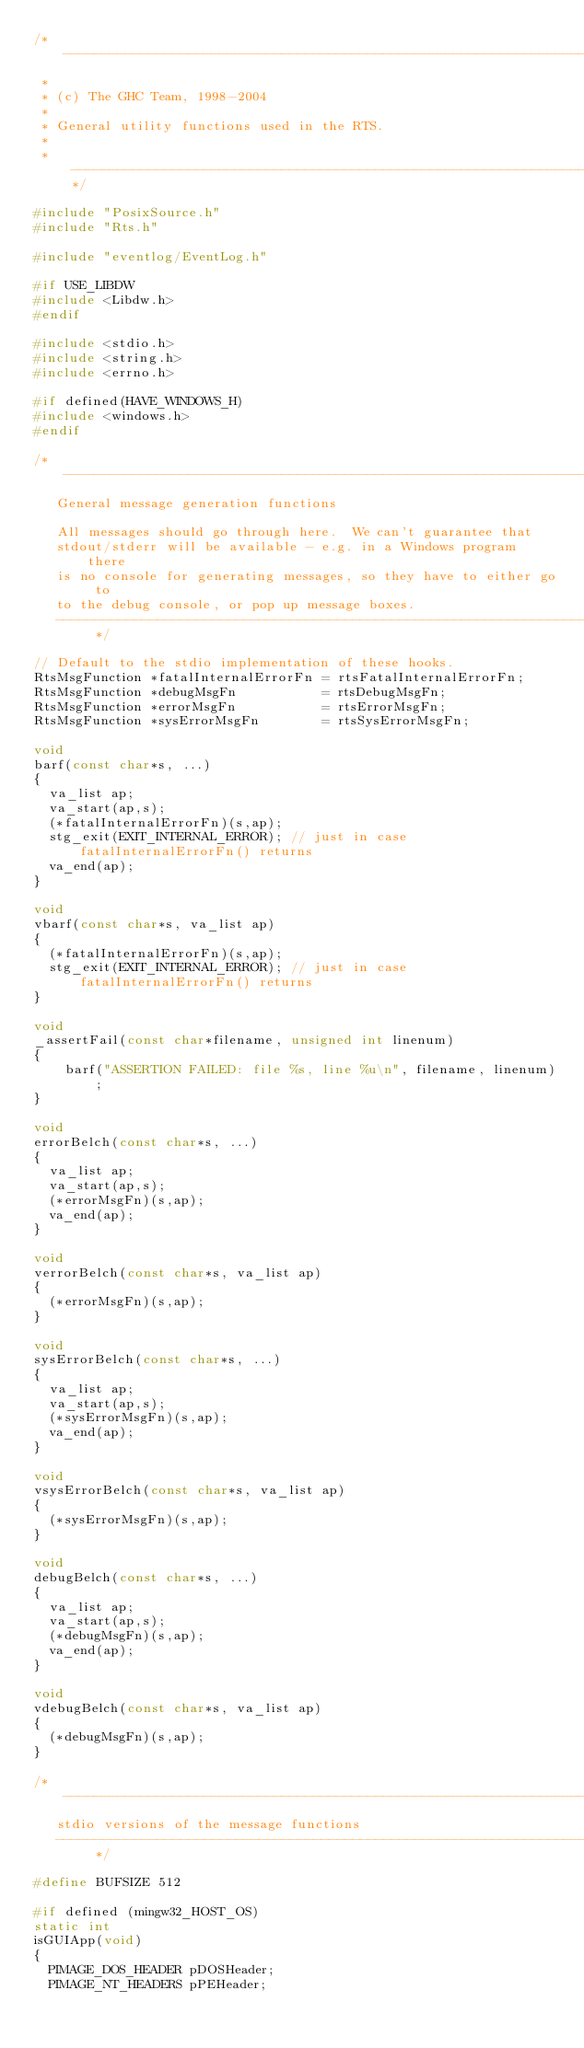<code> <loc_0><loc_0><loc_500><loc_500><_C_>/* -----------------------------------------------------------------------------
 *
 * (c) The GHC Team, 1998-2004
 *
 * General utility functions used in the RTS.
 *
 * ---------------------------------------------------------------------------*/

#include "PosixSource.h"
#include "Rts.h"

#include "eventlog/EventLog.h"

#if USE_LIBDW
#include <Libdw.h>
#endif

#include <stdio.h>
#include <string.h>
#include <errno.h>

#if defined(HAVE_WINDOWS_H)
#include <windows.h>
#endif

/* -----------------------------------------------------------------------------
   General message generation functions

   All messages should go through here.  We can't guarantee that
   stdout/stderr will be available - e.g. in a Windows program there
   is no console for generating messages, so they have to either go to
   to the debug console, or pop up message boxes.
   -------------------------------------------------------------------------- */

// Default to the stdio implementation of these hooks.
RtsMsgFunction *fatalInternalErrorFn = rtsFatalInternalErrorFn;
RtsMsgFunction *debugMsgFn           = rtsDebugMsgFn;
RtsMsgFunction *errorMsgFn           = rtsErrorMsgFn;
RtsMsgFunction *sysErrorMsgFn        = rtsSysErrorMsgFn;

void
barf(const char*s, ...)
{
  va_list ap;
  va_start(ap,s);
  (*fatalInternalErrorFn)(s,ap);
  stg_exit(EXIT_INTERNAL_ERROR); // just in case fatalInternalErrorFn() returns
  va_end(ap);
}

void
vbarf(const char*s, va_list ap)
{
  (*fatalInternalErrorFn)(s,ap);
  stg_exit(EXIT_INTERNAL_ERROR); // just in case fatalInternalErrorFn() returns
}

void
_assertFail(const char*filename, unsigned int linenum)
{
    barf("ASSERTION FAILED: file %s, line %u\n", filename, linenum);
}

void
errorBelch(const char*s, ...)
{
  va_list ap;
  va_start(ap,s);
  (*errorMsgFn)(s,ap);
  va_end(ap);
}

void
verrorBelch(const char*s, va_list ap)
{
  (*errorMsgFn)(s,ap);
}

void
sysErrorBelch(const char*s, ...)
{
  va_list ap;
  va_start(ap,s);
  (*sysErrorMsgFn)(s,ap);
  va_end(ap);
}

void
vsysErrorBelch(const char*s, va_list ap)
{
  (*sysErrorMsgFn)(s,ap);
}

void
debugBelch(const char*s, ...)
{
  va_list ap;
  va_start(ap,s);
  (*debugMsgFn)(s,ap);
  va_end(ap);
}

void
vdebugBelch(const char*s, va_list ap)
{
  (*debugMsgFn)(s,ap);
}

/* -----------------------------------------------------------------------------
   stdio versions of the message functions
   -------------------------------------------------------------------------- */

#define BUFSIZE 512

#if defined (mingw32_HOST_OS)
static int
isGUIApp(void)
{
  PIMAGE_DOS_HEADER pDOSHeader;
  PIMAGE_NT_HEADERS pPEHeader;
</code> 